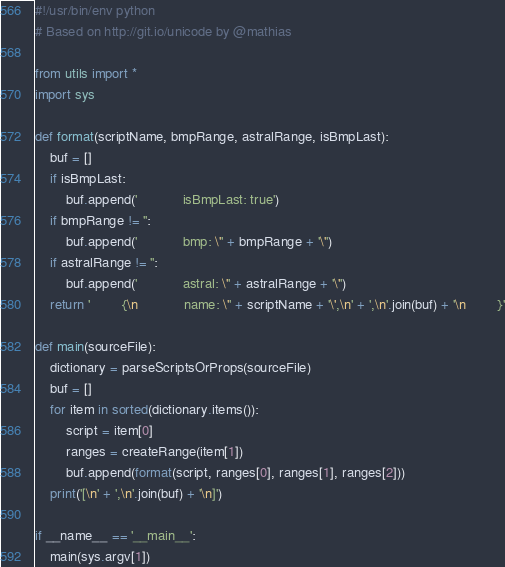<code> <loc_0><loc_0><loc_500><loc_500><_Python_>#!/usr/bin/env python
# Based on http://git.io/unicode by @mathias

from utils import *
import sys

def format(scriptName, bmpRange, astralRange, isBmpLast):
	buf = []
	if isBmpLast:
		buf.append('            isBmpLast: true')
	if bmpRange != '':
		buf.append('            bmp: \'' + bmpRange + '\'')
	if astralRange != '':
		buf.append('            astral: \'' + astralRange + '\'')
	return '        {\n            name: \'' + scriptName + '\',\n' + ',\n'.join(buf) + '\n        }'

def main(sourceFile):
	dictionary = parseScriptsOrProps(sourceFile)
	buf = []
	for item in sorted(dictionary.items()):
		script = item[0]
		ranges = createRange(item[1])
		buf.append(format(script, ranges[0], ranges[1], ranges[2]))
	print('[\n' + ',\n'.join(buf) + '\n]')

if __name__ == '__main__':
	main(sys.argv[1])</code> 